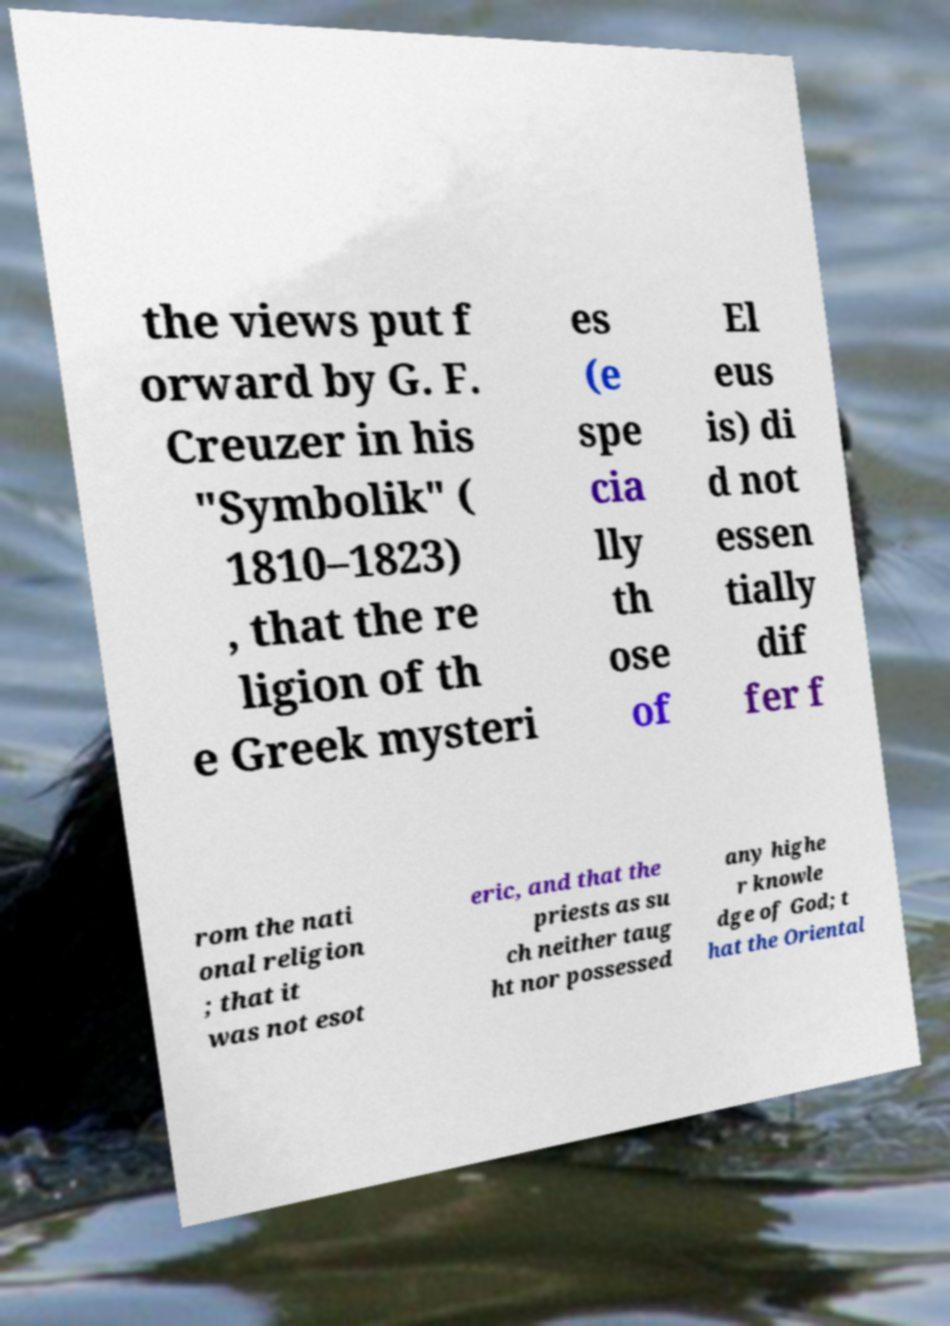Can you read and provide the text displayed in the image?This photo seems to have some interesting text. Can you extract and type it out for me? the views put f orward by G. F. Creuzer in his "Symbolik" ( 1810–1823) , that the re ligion of th e Greek mysteri es (e spe cia lly th ose of El eus is) di d not essen tially dif fer f rom the nati onal religion ; that it was not esot eric, and that the priests as su ch neither taug ht nor possessed any highe r knowle dge of God; t hat the Oriental 